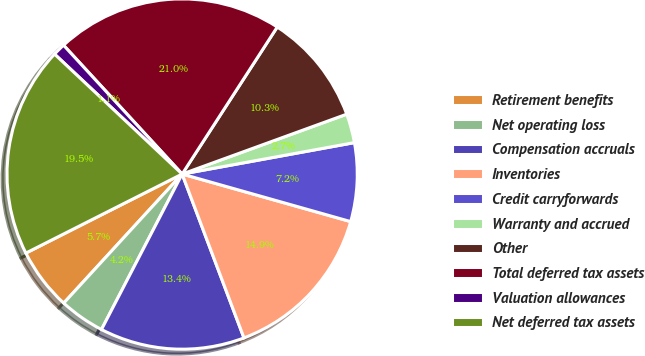Convert chart to OTSL. <chart><loc_0><loc_0><loc_500><loc_500><pie_chart><fcel>Retirement benefits<fcel>Net operating loss<fcel>Compensation accruals<fcel>Inventories<fcel>Credit carryforwards<fcel>Warranty and accrued<fcel>Other<fcel>Total deferred tax assets<fcel>Valuation allowances<fcel>Net deferred tax assets<nl><fcel>5.73%<fcel>4.2%<fcel>13.36%<fcel>14.88%<fcel>7.25%<fcel>2.68%<fcel>10.31%<fcel>20.98%<fcel>1.15%<fcel>19.46%<nl></chart> 